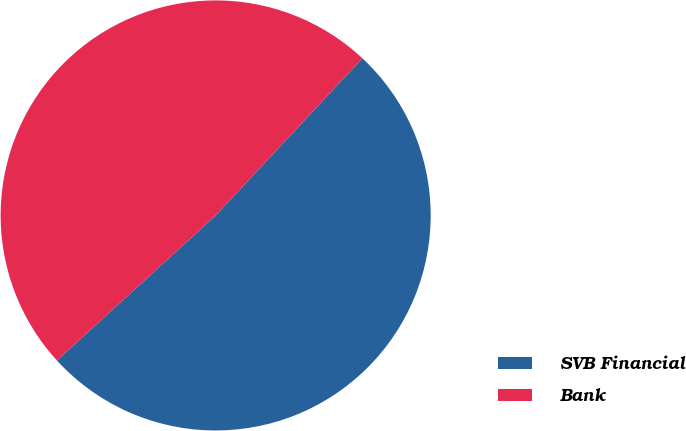<chart> <loc_0><loc_0><loc_500><loc_500><pie_chart><fcel>SVB Financial<fcel>Bank<nl><fcel>51.26%<fcel>48.74%<nl></chart> 